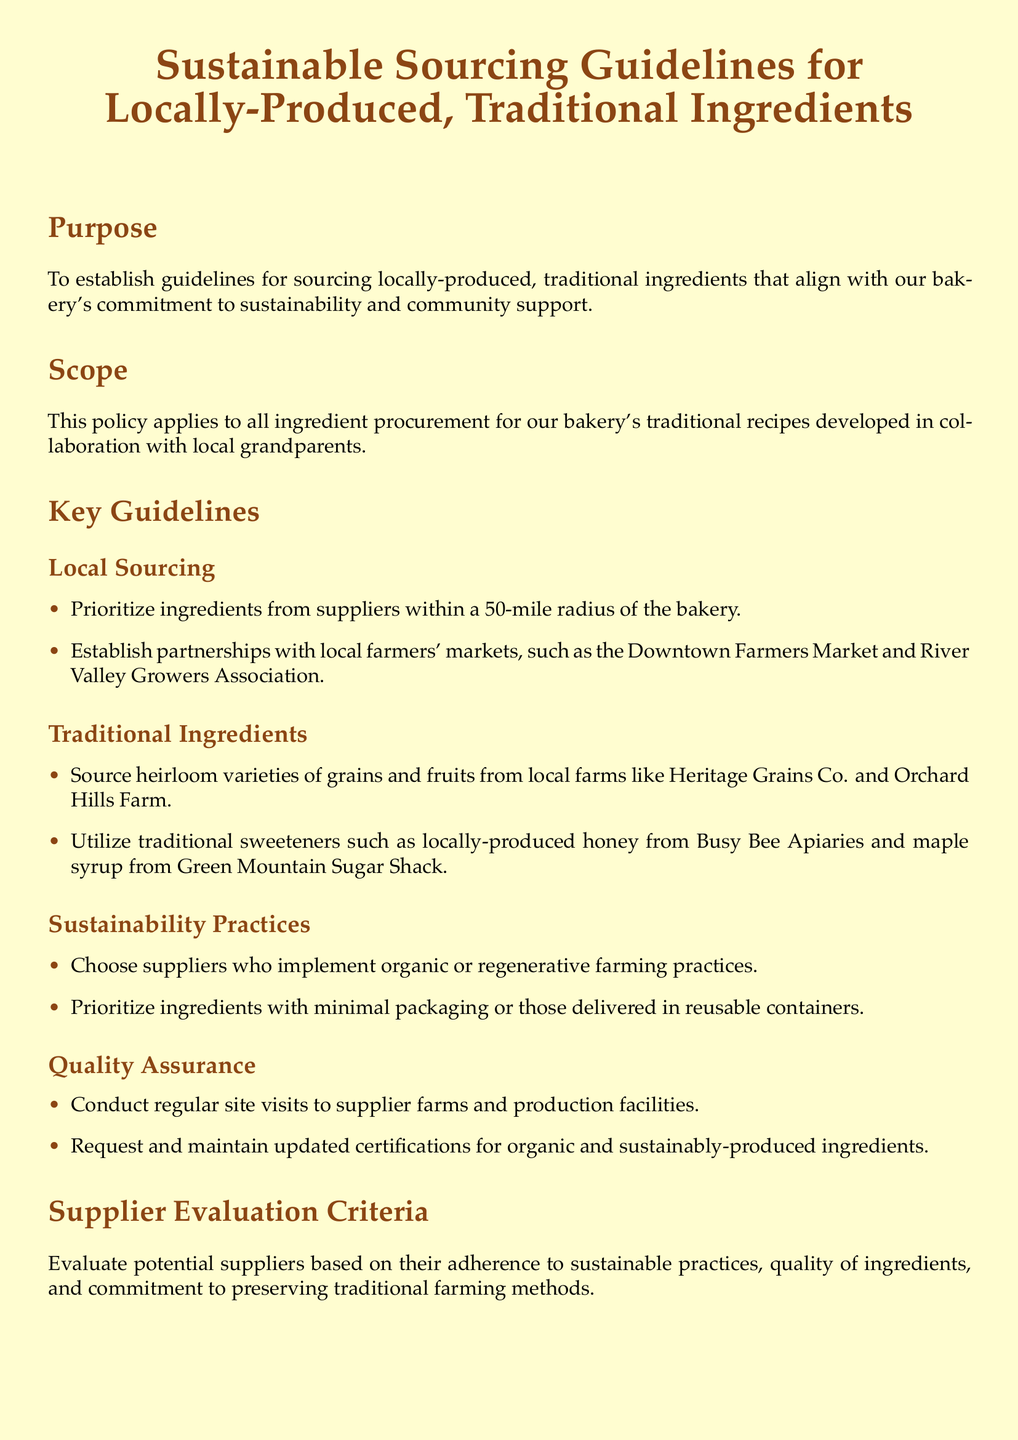What is the purpose of the guidelines? The purpose is to establish guidelines for sourcing locally-produced, traditional ingredients that align with the bakery's commitment to sustainability and community support.
Answer: To establish guidelines for sourcing locally-produced, traditional ingredients What is the radius for local sourcing? The document specifies a 50-mile radius for ingredient sourcing from the bakery.
Answer: 50-mile radius Which farmers' market is mentioned in the guidelines? The guidelines mention the Downtown Farmers Market as a potential partnership for sourcing ingredients.
Answer: Downtown Farmers Market What types of sweeteners are prioritized? The document specifies traditional sweeteners such as locally-produced honey and maple syrup.
Answer: Honey and maple syrup How often will the policy be reviewed? The policy states that it will be reviewed annually.
Answer: Annually What is required for quality assurance? The document emphasizes the need for regular site visits to supplier farms and maintaining updated certifications.
Answer: Regular site visits and updated certifications Who should suppliers implement farming practices? Suppliers are expected to implement organic or regenerative farming practices.
Answer: Organic or regenerative farming practices What is the main focus of supplier evaluation criteria? The evaluation focuses on sustainable practices, quality of ingredients, and preserving traditional farming methods.
Answer: Sustainable practices, quality of ingredients, and preserving traditional farming methods 